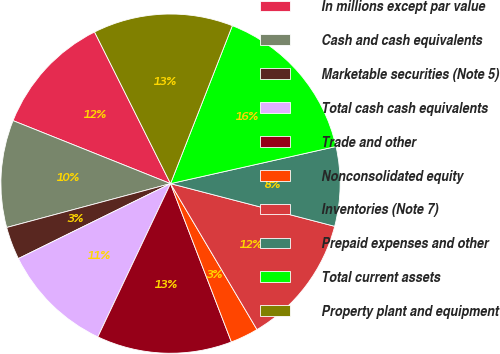Convert chart. <chart><loc_0><loc_0><loc_500><loc_500><pie_chart><fcel>In millions except par value<fcel>Cash and cash equivalents<fcel>Marketable securities (Note 5)<fcel>Total cash cash equivalents<fcel>Trade and other<fcel>Nonconsolidated equity<fcel>Inventories (Note 7)<fcel>Prepaid expenses and other<fcel>Total current assets<fcel>Property plant and equipment<nl><fcel>11.55%<fcel>10.22%<fcel>3.12%<fcel>10.67%<fcel>12.89%<fcel>2.67%<fcel>12.44%<fcel>7.56%<fcel>15.55%<fcel>13.33%<nl></chart> 